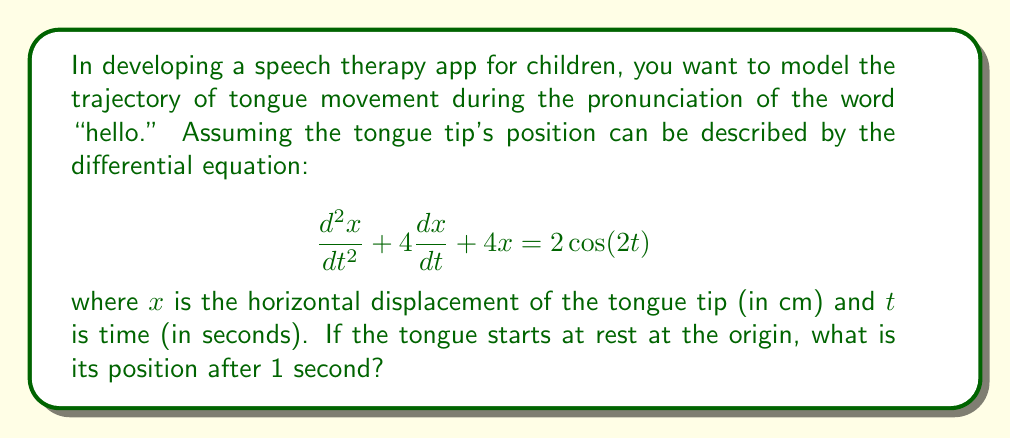Provide a solution to this math problem. To solve this problem, we need to follow these steps:

1) First, recognize that this is a second-order non-homogeneous differential equation.

2) The general solution will be the sum of the complementary function (solution to the homogeneous equation) and the particular integral (solution to the non-homogeneous part).

3) For the complementary function, the characteristic equation is:
   $$r^2 + 4r + 4 = 0$$
   $$(r + 2)^2 = 0$$
   $$r = -2 \text{ (repeated root)}$$

   So the complementary function is:
   $$x_c = (A + Bt)e^{-2t}$$

4) For the particular integral, we can use the method of undetermined coefficients. Try:
   $$x_p = a\cos(2t) + b\sin(2t)$$

   Substituting this into the original equation and solving for $a$ and $b$, we get:
   $$x_p = \frac{1}{5}\cos(2t) - \frac{2}{5}\sin(2t)$$

5) The general solution is thus:
   $$x = (A + Bt)e^{-2t} + \frac{1}{5}\cos(2t) - \frac{2}{5}\sin(2t)$$

6) To find $A$ and $B$, we use the initial conditions:
   At $t=0$, $x=0$ and $\frac{dx}{dt}=0$

   From $x(0)=0$:
   $$0 = A + \frac{1}{5}$$
   $$A = -\frac{1}{5}$$

   From $\frac{dx}{dt}(0)=0$:
   $$0 = B - 2A - \frac{4}{5}$$
   $$B = -\frac{3}{5}$$

7) Therefore, the particular solution is:
   $$x = (-\frac{1}{5} - \frac{3}{5}t)e^{-2t} + \frac{1}{5}\cos(2t) - \frac{2}{5}\sin(2t)$$

8) To find the position after 1 second, we evaluate $x(1)$:
   $$x(1) = (-\frac{1}{5} - \frac{3}{5})e^{-2} + \frac{1}{5}\cos(2) - \frac{2}{5}\sin(2)$$
   $$\approx -0.0859 \text{ cm}$$
Answer: $-0.0859$ cm 